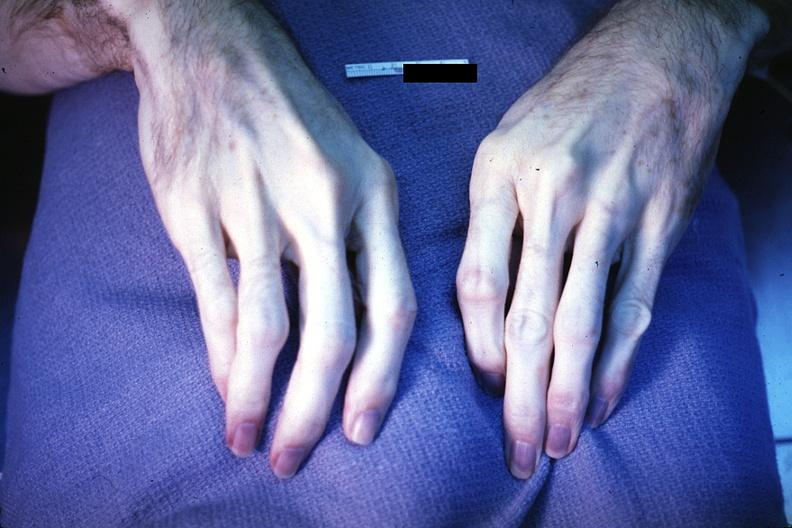does this image show excellent example of acrocyanosis?
Answer the question using a single word or phrase. Yes 